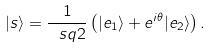<formula> <loc_0><loc_0><loc_500><loc_500>| s \rangle = \frac { 1 } { \ s q { 2 } } \left ( | e _ { 1 } \rangle + e ^ { i \theta } | e _ { 2 } \rangle \right ) .</formula> 